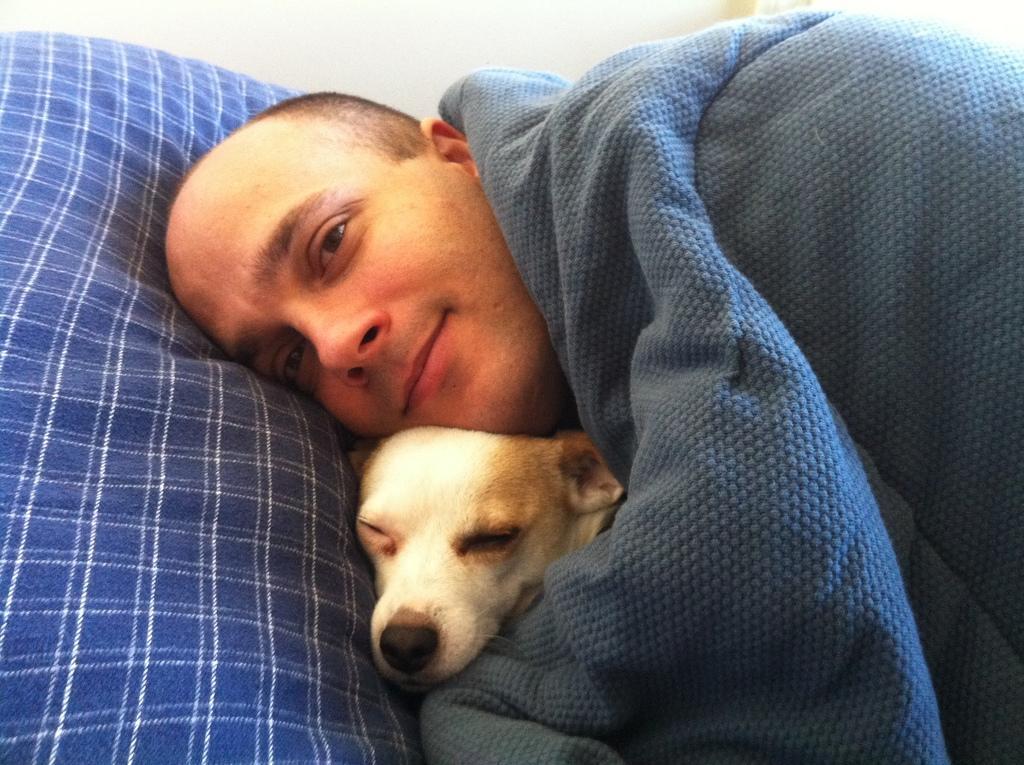How would you summarize this image in a sentence or two? As we can see in the image there is a man and a dog. 